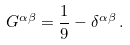<formula> <loc_0><loc_0><loc_500><loc_500>G ^ { \alpha \beta } = \frac { 1 } { 9 } - \delta ^ { \alpha \beta } \, .</formula> 